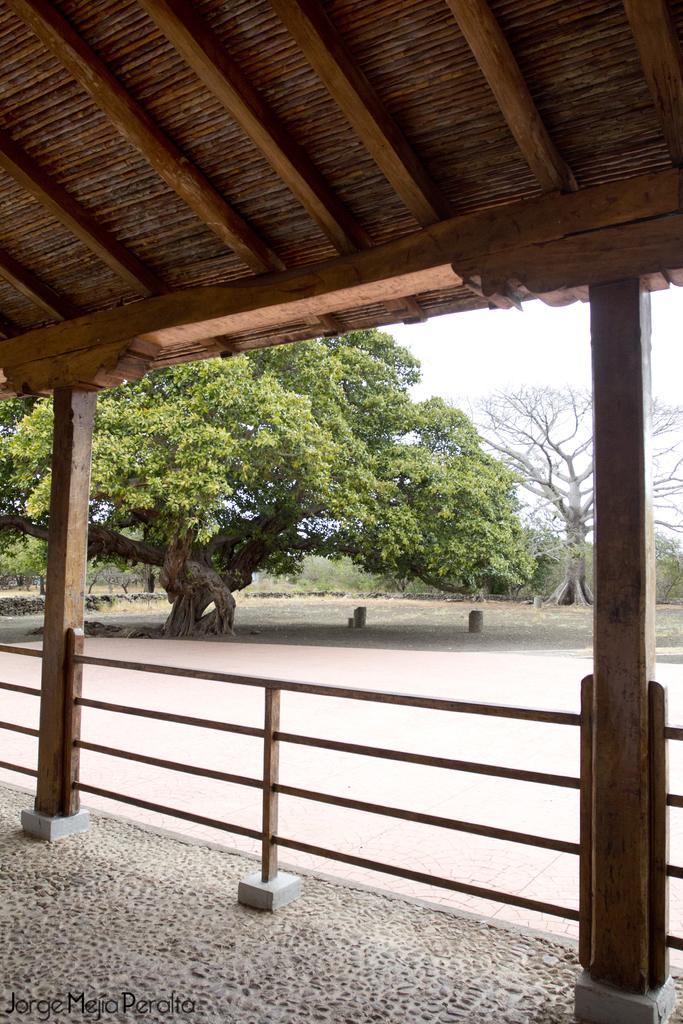Could you give a brief overview of what you see in this image? In this image we can see the wooden roof top with supporting poles and in the middle we can see some trees. 